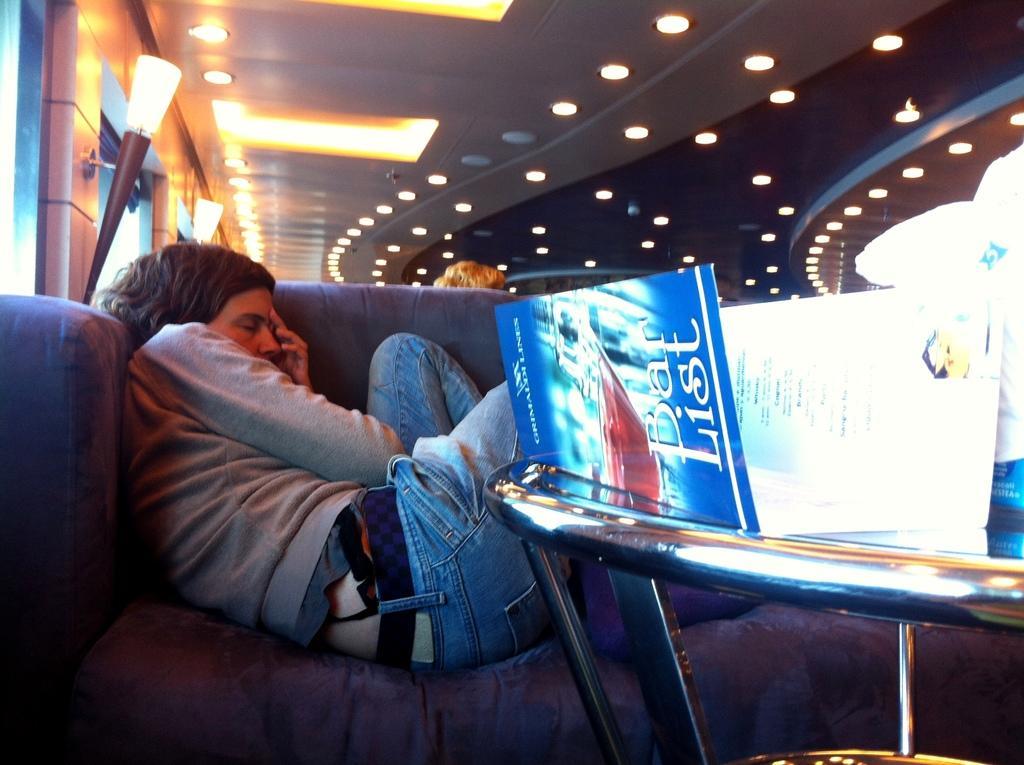How would you summarize this image in a sentence or two? In the image we can see a person wearing clothes and the person is lying on the sofa. There is a sofa, light and a table. On the table we can see there are other objects. 